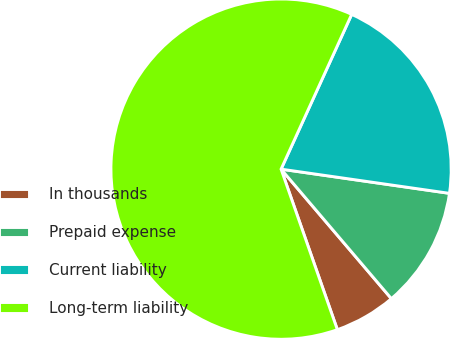<chart> <loc_0><loc_0><loc_500><loc_500><pie_chart><fcel>In thousands<fcel>Prepaid expense<fcel>Current liability<fcel>Long-term liability<nl><fcel>5.86%<fcel>11.5%<fcel>20.46%<fcel>62.18%<nl></chart> 